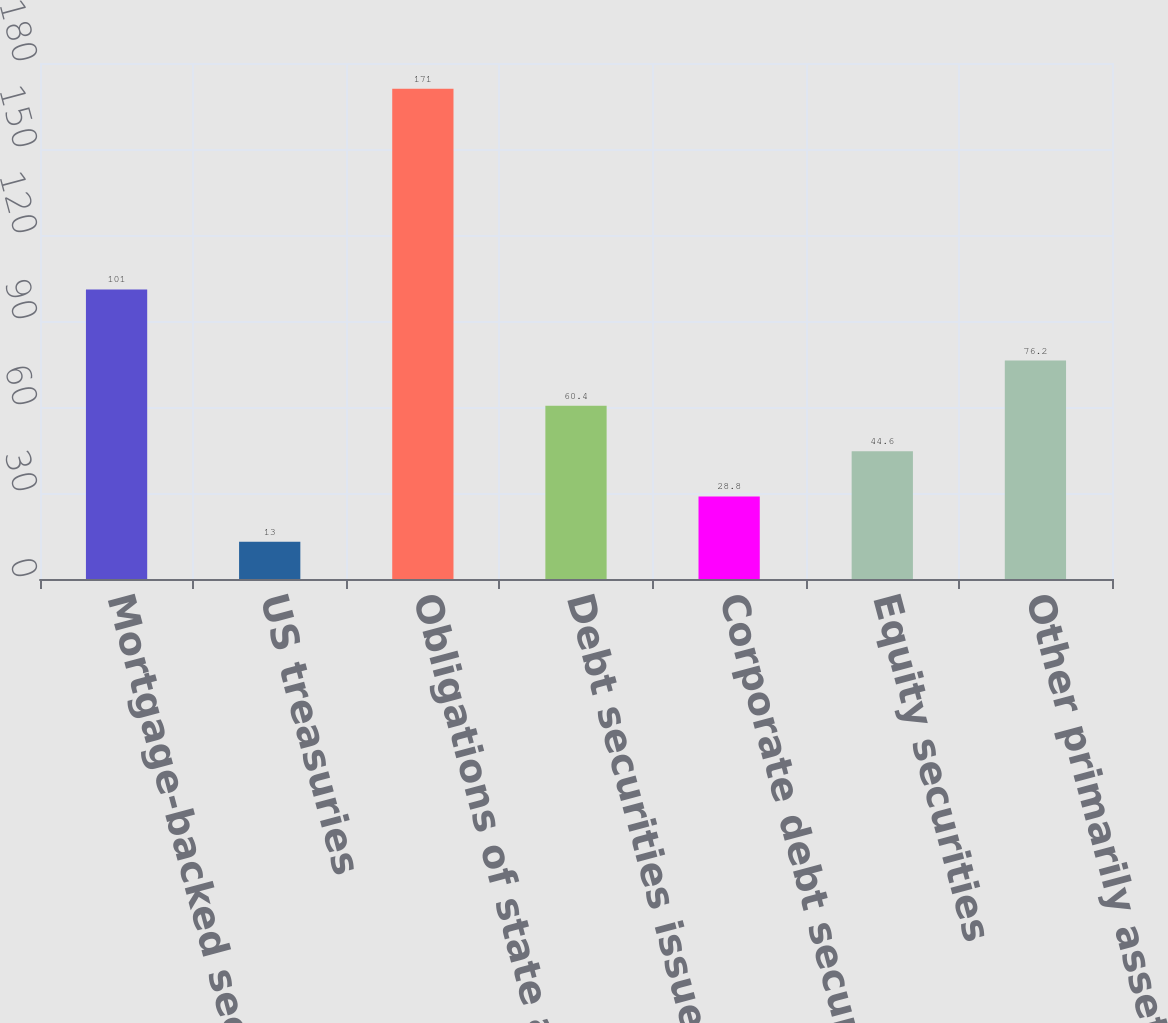Convert chart to OTSL. <chart><loc_0><loc_0><loc_500><loc_500><bar_chart><fcel>Mortgage-backed securities<fcel>US treasuries<fcel>Obligations of state and<fcel>Debt securities issued by<fcel>Corporate debt securities<fcel>Equity securities<fcel>Other primarily asset-backed<nl><fcel>101<fcel>13<fcel>171<fcel>60.4<fcel>28.8<fcel>44.6<fcel>76.2<nl></chart> 